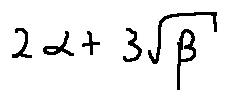Convert formula to latex. <formula><loc_0><loc_0><loc_500><loc_500>2 \alpha + 3 \sqrt { \beta }</formula> 